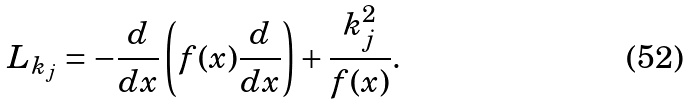<formula> <loc_0><loc_0><loc_500><loc_500>L _ { k _ { j } } = - \frac { d } { d x } \left ( f ( x ) \frac { d } { d x } \right ) + \frac { k _ { j } ^ { 2 } } { f ( x ) } .</formula> 